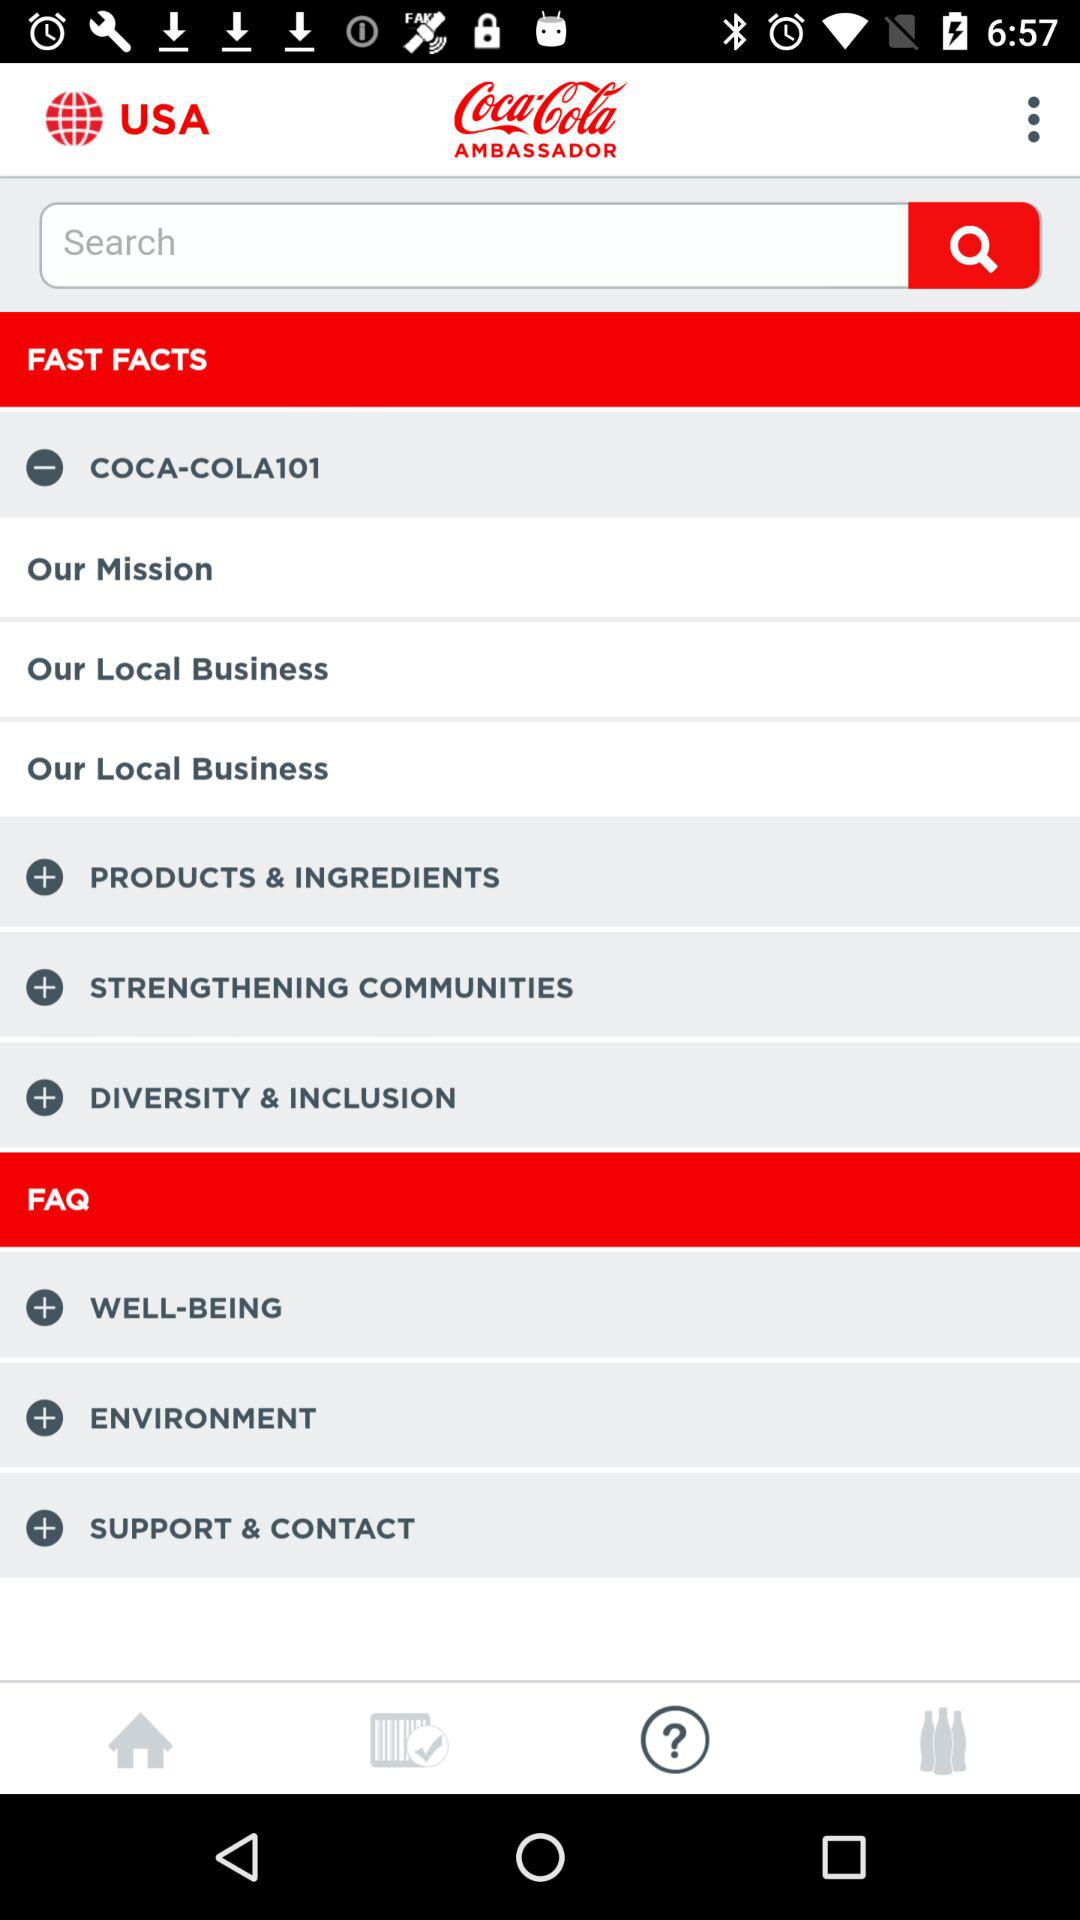Who is this application powered by?
When the provided information is insufficient, respond with <no answer>. <no answer> 